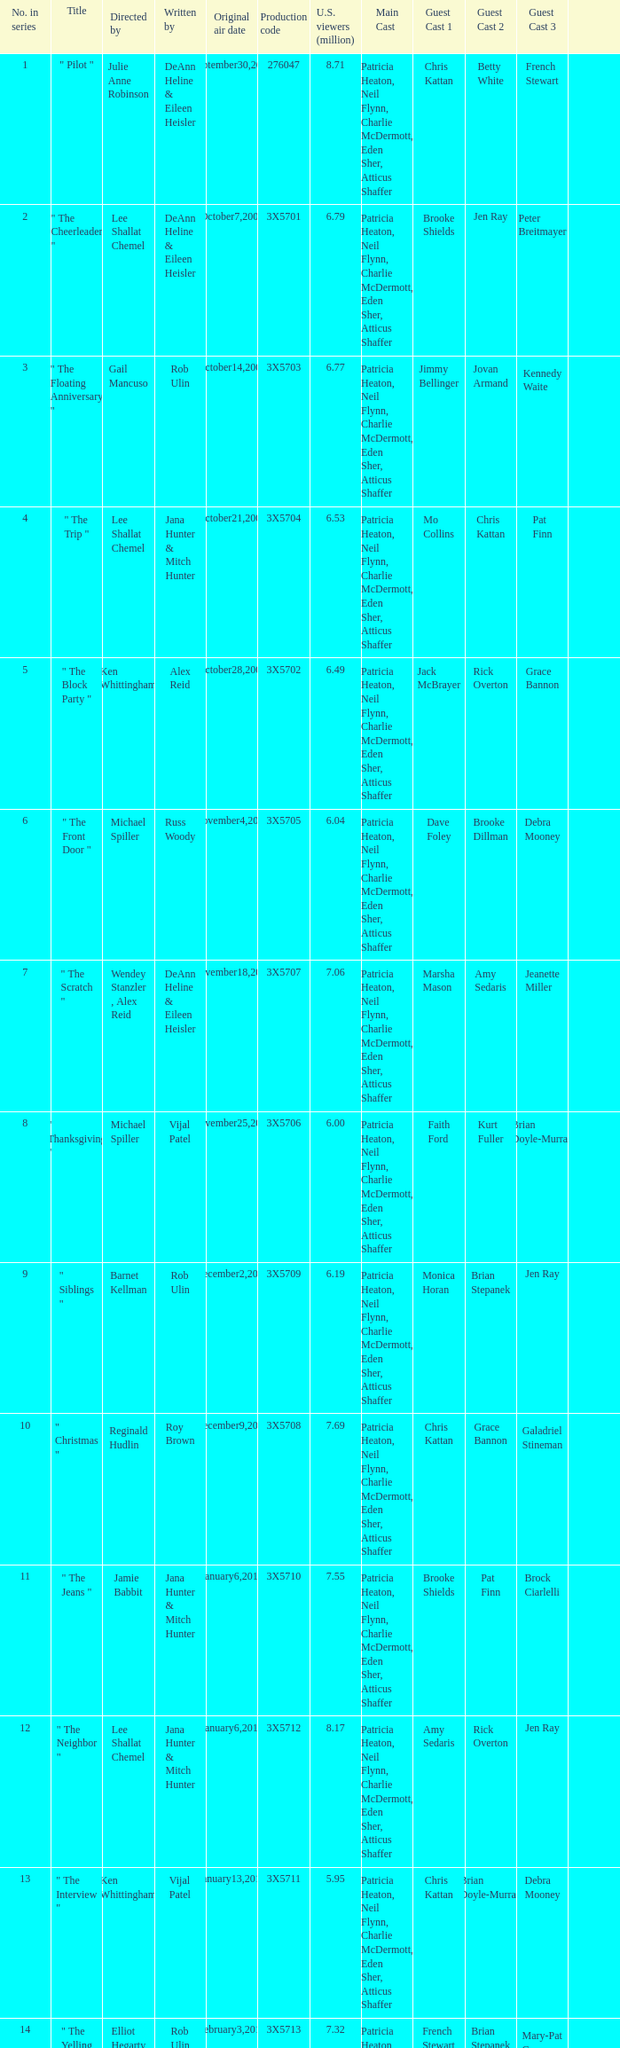What is the title of the episode Alex Reid directed? "The Final Four". Could you help me parse every detail presented in this table? {'header': ['No. in series', 'Title', 'Directed by', 'Written by', 'Original air date', 'Production code', 'U.S. viewers (million)', 'Main Cast', 'Guest Cast 1', 'Guest Cast 2', 'Guest Cast 3', ''], 'rows': [['1', '" Pilot "', 'Julie Anne Robinson', 'DeAnn Heline & Eileen Heisler', 'September30,2009', '276047', '8.71', 'Patricia Heaton, Neil Flynn, Charlie McDermott, Eden Sher, Atticus Shaffer', 'Chris Kattan', 'Betty White', 'French Stewart', ''], ['2', '" The Cheerleader "', 'Lee Shallat Chemel', 'DeAnn Heline & Eileen Heisler', 'October7,2009', '3X5701', '6.79', 'Patricia Heaton, Neil Flynn, Charlie McDermott, Eden Sher, Atticus Shaffer', 'Brooke Shields', 'Jen Ray', 'Peter Breitmayer', ''], ['3', '" The Floating Anniversary "', 'Gail Mancuso', 'Rob Ulin', 'October14,2009', '3X5703', '6.77', 'Patricia Heaton, Neil Flynn, Charlie McDermott, Eden Sher, Atticus Shaffer', 'Jimmy Bellinger', 'Jovan Armand', 'Kennedy Waite', ''], ['4', '" The Trip "', 'Lee Shallat Chemel', 'Jana Hunter & Mitch Hunter', 'October21,2009', '3X5704', '6.53', 'Patricia Heaton, Neil Flynn, Charlie McDermott, Eden Sher, Atticus Shaffer', 'Mo Collins', 'Chris Kattan', 'Pat Finn', ''], ['5', '" The Block Party "', 'Ken Whittingham', 'Alex Reid', 'October28,2009', '3X5702', '6.49', 'Patricia Heaton, Neil Flynn, Charlie McDermott, Eden Sher, Atticus Shaffer', 'Jack McBrayer', 'Rick Overton', 'Grace Bannon', ''], ['6', '" The Front Door "', 'Michael Spiller', 'Russ Woody', 'November4,2009', '3X5705', '6.04', 'Patricia Heaton, Neil Flynn, Charlie McDermott, Eden Sher, Atticus Shaffer', 'Dave Foley', 'Brooke Dillman', 'Debra Mooney', ''], ['7', '" The Scratch "', 'Wendey Stanzler , Alex Reid', 'DeAnn Heline & Eileen Heisler', 'November18,2009', '3X5707', '7.06', 'Patricia Heaton, Neil Flynn, Charlie McDermott, Eden Sher, Atticus Shaffer', 'Marsha Mason', 'Amy Sedaris', 'Jeanette Miller', ''], ['8', '" Thanksgiving "', 'Michael Spiller', 'Vijal Patel', 'November25,2009', '3X5706', '6.00', 'Patricia Heaton, Neil Flynn, Charlie McDermott, Eden Sher, Atticus Shaffer', 'Faith Ford', 'Kurt Fuller', 'Brian Doyle-Murray', ''], ['9', '" Siblings "', 'Barnet Kellman', 'Rob Ulin', 'December2,2009', '3X5709', '6.19', 'Patricia Heaton, Neil Flynn, Charlie McDermott, Eden Sher, Atticus Shaffer', 'Monica Horan', 'Brian Stepanek', 'Jen Ray', ''], ['10', '" Christmas "', 'Reginald Hudlin', 'Roy Brown', 'December9,2009', '3X5708', '7.69', 'Patricia Heaton, Neil Flynn, Charlie McDermott, Eden Sher, Atticus Shaffer', 'Chris Kattan', 'Grace Bannon', 'Galadriel Stineman', ''], ['11', '" The Jeans "', 'Jamie Babbit', 'Jana Hunter & Mitch Hunter', 'January6,2010', '3X5710', '7.55', 'Patricia Heaton, Neil Flynn, Charlie McDermott, Eden Sher, Atticus Shaffer', 'Brooke Shields', 'Pat Finn', 'Brock Ciarlelli', ''], ['12', '" The Neighbor "', 'Lee Shallat Chemel', 'Jana Hunter & Mitch Hunter', 'January6,2010', '3X5712', '8.17', 'Patricia Heaton, Neil Flynn, Charlie McDermott, Eden Sher, Atticus Shaffer', 'Amy Sedaris', 'Rick Overton', 'Jen Ray', ''], ['13', '" The Interview "', 'Ken Whittingham', 'Vijal Patel', 'January13,2010', '3X5711', '5.95', 'Patricia Heaton, Neil Flynn, Charlie McDermott, Eden Sher, Atticus Shaffer', 'Chris Kattan', 'Brian Doyle-Murray', 'Debra Mooney', ''], ['14', '" The Yelling "', 'Elliot Hegarty', 'Rob Ulin', 'February3,2010', '3X5713', '7.32', 'Patricia Heaton, Neil Flynn, Charlie McDermott, Eden Sher, Atticus Shaffer', 'French Stewart', 'Brian Stepanek', 'Mary-Pat Green', ''], ['15', '" Valentine\'s Day "', 'Chris Koch', 'Bruce Rasmussen', 'February10,2010', '3X5714', '7.83', 'Patricia Heaton, Neil Flynn, Charlie McDermott, Eden Sher, Atticus Shaffer', 'Krista Braun', 'Dave Foley', 'Marsha Mason', ''], ['16', '" The Bee "', 'Ken Whittingham', 'Eileen Heisler & DeAnn Heline', 'March3,2010', '3X5717', '6.02', 'Patricia Heaton, Neil Flynn, Charlie McDermott, Eden Sher, Atticus Shaffer', 'Brian Doyle-Murray', 'Molly Shannon', 'Jack McBrayer', ''], ['17', '"The Break-Up"', 'Wendey Stanzler', 'Vijal Patel', 'March10,2010', '3X5715', '6.32', 'Patricia Heaton, Neil Flynn, Charlie McDermott, Eden Sher, Atticus Shaffer', 'Chris Kattan', 'Jen Ray', "Sean O'Bryan", ''], ['18', '"The Fun House"', 'Chris Koch', 'Roy Brown', 'March24,2010', '3X5716', '7.16', 'Patricia Heaton, Neil Flynn, Charlie McDermott, Eden Sher, Atticus Shaffer', 'Brooke Shields', 'Molly Schreiber', 'Carlos Jacott', ''], ['19', '"The Final Four"', 'Alex Reid', 'Rob Ulin', 'March31,2010', '3X5719', '6.23', 'Patricia Heaton, Neil Flynn, Charlie McDermott, Eden Sher, Atticus Shaffer', 'French Stewart', 'Betty White', 'Jen Ray', ''], ['20', '"TV or Not TV"', 'Lee Shallat Chemel', 'Vijal Patel', 'April14,2010', '3X5718', '6.70', 'Patricia Heaton, Neil Flynn, Charlie McDermott, Eden Sher, Atticus Shaffer', 'Jack McBrayer', 'Jen Ray', 'Sarah Wright Olsen', ''], ['21', '"Worry Duty"', 'Lee Shallat Chemel', 'Bruce Rasmussen', 'April28,2010', '3X5720', '7.10', 'Patricia Heaton, Neil Flynn, Charlie McDermott, Eden Sher, Atticus Shaffer', 'Rachel Dratch', 'Pat Finn', 'Mindy Cohn', ''], ['22', '"Mother\'s Day"', 'Barnet Kellman', 'Mitch Hunter & Jana Hunter', 'May5,2010', '3X5721', '6.75', 'Patricia Heaton, Neil Flynn, Charlie McDermott, Eden Sher, Atticus Shaffer', 'Amy Sedaris', 'Betty White', 'Blaine Saunders', ''], ['23', '"Signals"', 'Jamie Babbit', 'DeAnn Heline & Eileen Heisler', 'May12,2010', '3X5722', '7.49', 'Patricia Heaton, Neil Flynn, Charlie McDermott, Eden Sher, Atticus Shaffer', 'Dave Foley', 'Marsha Mason', 'Jen Ray', '']]} 